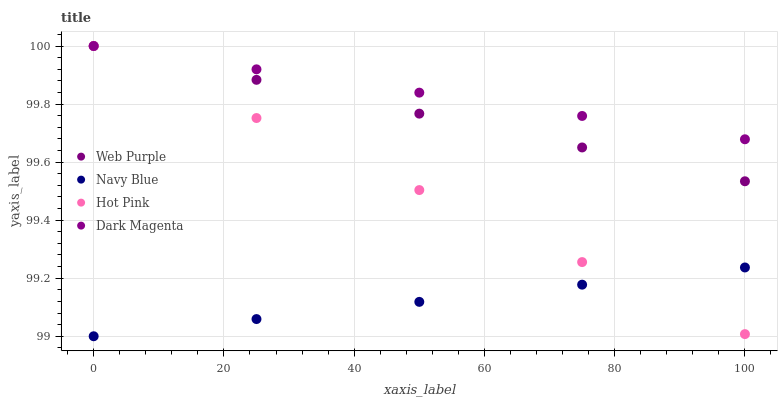Does Navy Blue have the minimum area under the curve?
Answer yes or no. Yes. Does Dark Magenta have the maximum area under the curve?
Answer yes or no. Yes. Does Web Purple have the minimum area under the curve?
Answer yes or no. No. Does Web Purple have the maximum area under the curve?
Answer yes or no. No. Is Navy Blue the smoothest?
Answer yes or no. Yes. Is Dark Magenta the roughest?
Answer yes or no. Yes. Is Web Purple the smoothest?
Answer yes or no. No. Is Web Purple the roughest?
Answer yes or no. No. Does Navy Blue have the lowest value?
Answer yes or no. Yes. Does Web Purple have the lowest value?
Answer yes or no. No. Does Dark Magenta have the highest value?
Answer yes or no. Yes. Is Navy Blue less than Dark Magenta?
Answer yes or no. Yes. Is Web Purple greater than Navy Blue?
Answer yes or no. Yes. Does Hot Pink intersect Web Purple?
Answer yes or no. Yes. Is Hot Pink less than Web Purple?
Answer yes or no. No. Is Hot Pink greater than Web Purple?
Answer yes or no. No. Does Navy Blue intersect Dark Magenta?
Answer yes or no. No. 